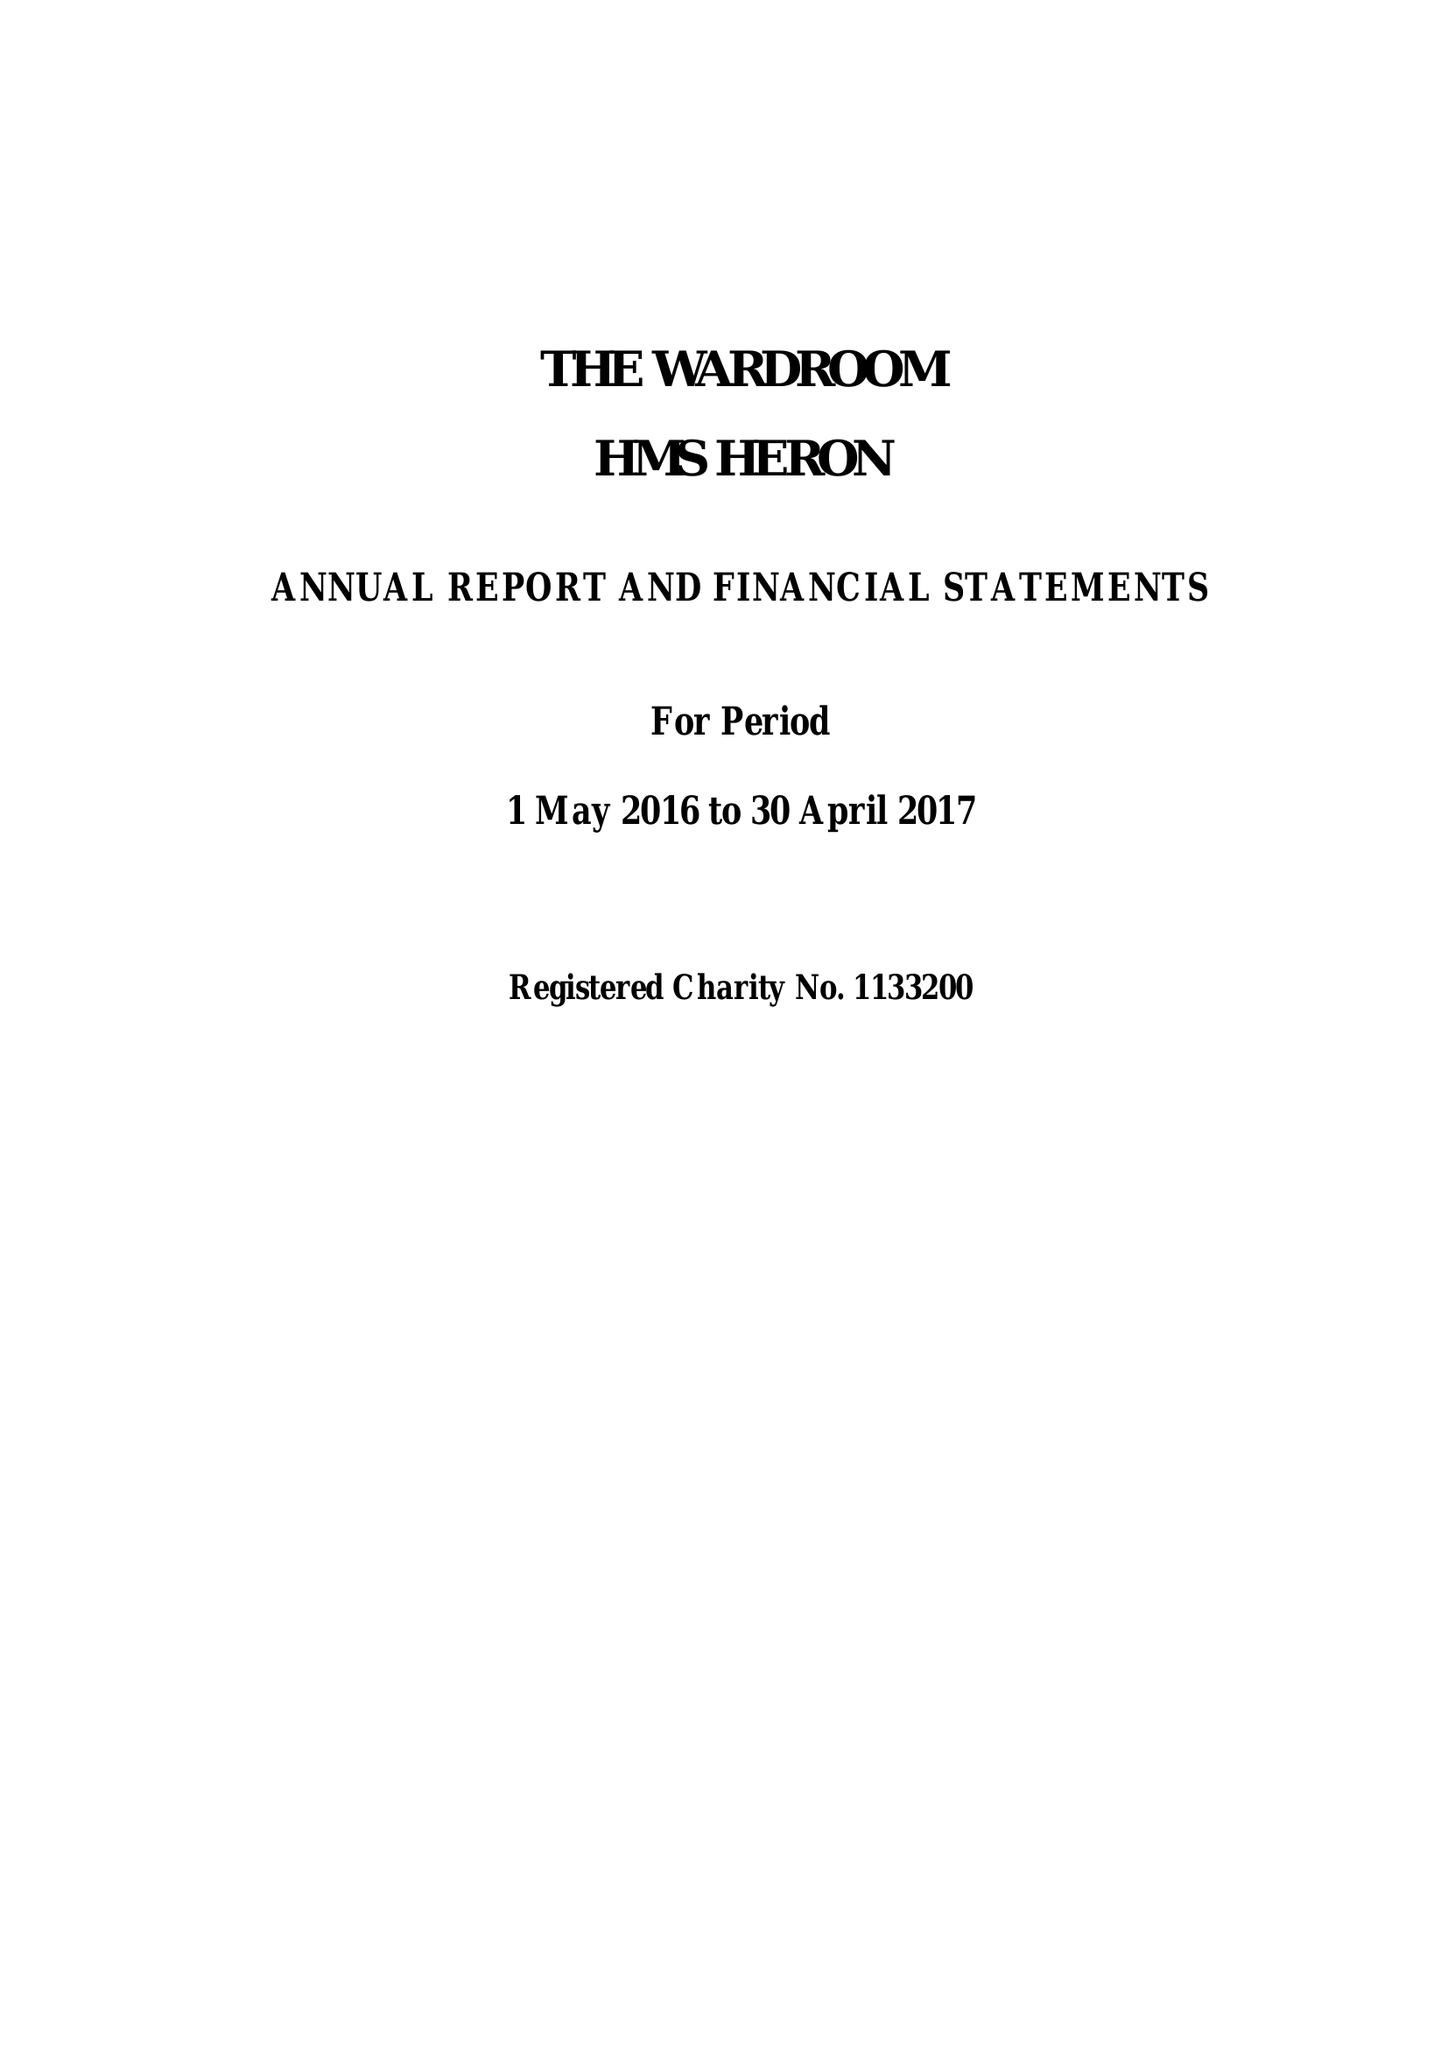What is the value for the charity_number?
Answer the question using a single word or phrase. 1133200 